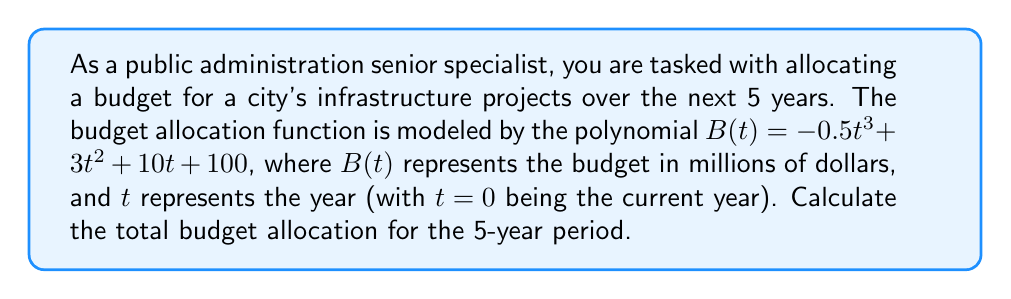Can you answer this question? To solve this problem, we need to follow these steps:

1) The total budget allocation for the 5-year period is the sum of the budgets for years 1 through 5.

2) We need to calculate $B(1)$, $B(2)$, $B(3)$, $B(4)$, and $B(5)$, then add these values.

3) Let's calculate each year's budget:

   For $t=1$: $B(1) = -0.5(1)^3 + 3(1)^2 + 10(1) + 100 = -0.5 + 3 + 10 + 100 = 112.5$

   For $t=2$: $B(2) = -0.5(2)^3 + 3(2)^2 + 10(2) + 100 = -4 + 12 + 20 + 100 = 128$

   For $t=3$: $B(3) = -0.5(3)^3 + 3(3)^2 + 10(3) + 100 = -13.5 + 27 + 30 + 100 = 143.5$

   For $t=4$: $B(4) = -0.5(4)^3 + 3(4)^2 + 10(4) + 100 = -32 + 48 + 40 + 100 = 156$

   For $t=5$: $B(5) = -0.5(5)^3 + 3(5)^2 + 10(5) + 100 = -62.5 + 75 + 50 + 100 = 162.5$

4) Now, we sum these values:

   Total Budget = $112.5 + 128 + 143.5 + 156 + 162.5 = 702.5$

Therefore, the total budget allocation for the 5-year period is 702.5 million dollars.
Answer: $702.5 million 